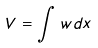<formula> <loc_0><loc_0><loc_500><loc_500>V = \int w d x</formula> 